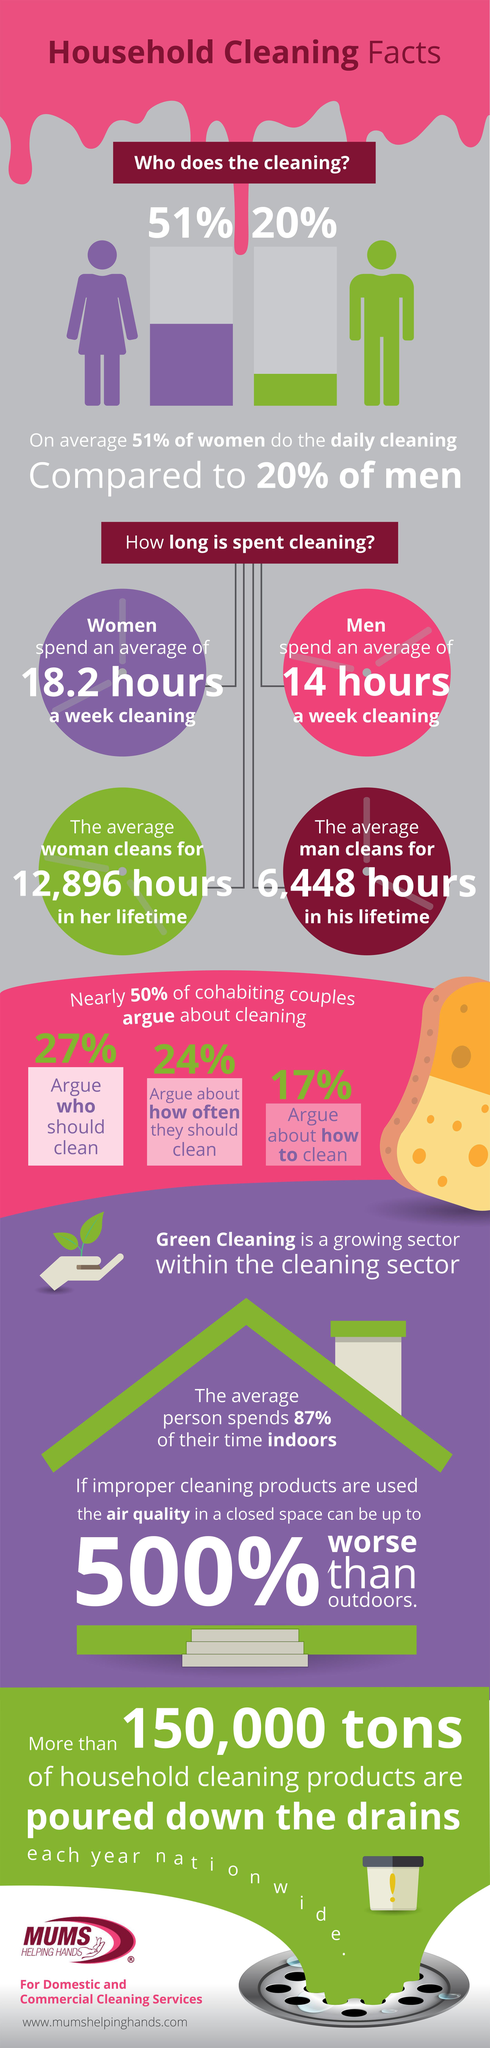Mention a couple of crucial points in this snapshot. A significant percentage of couples do not argue about who should clean, with 73% reporting that they share household responsibilities equally. According to the survey, 24% of couples argue about how often they should clean. The average man spends approximately 6,448 hours cleaning throughout his lifetime. According to a recent survey, only 13% of people's time is spent outdoors, which highlights the need for encouraging outdoor activities and promoting a healthy lifestyle. The amount of time that men typically spend on cleaning in a week is 14 hours. 